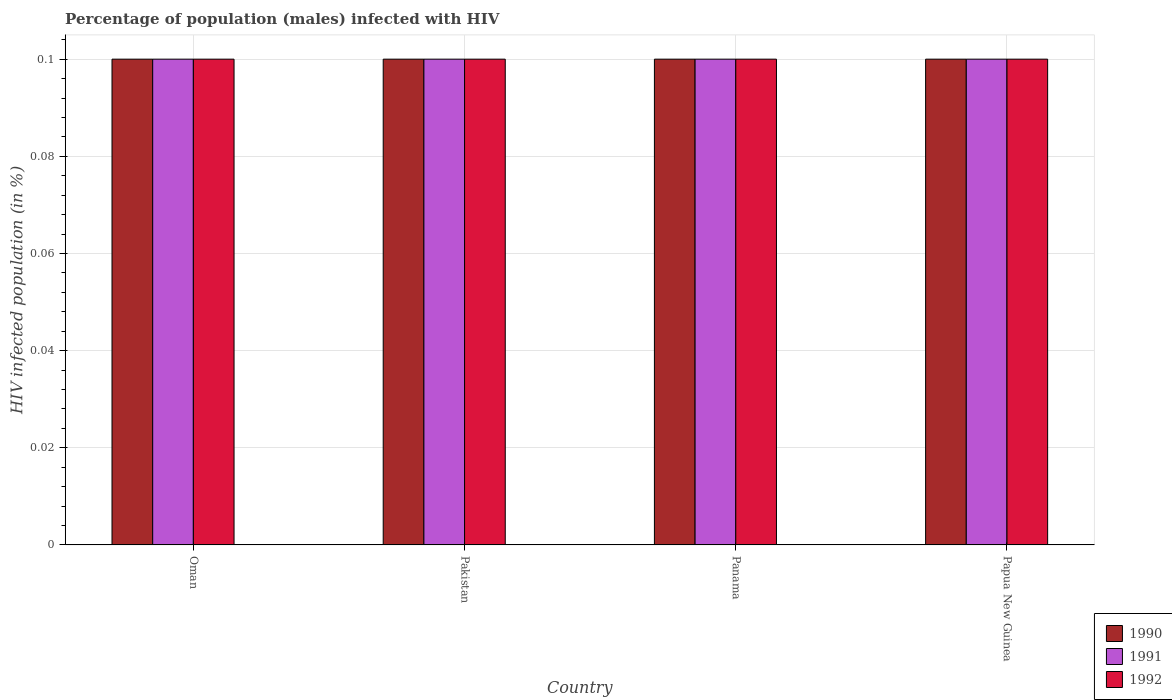How many groups of bars are there?
Give a very brief answer. 4. How many bars are there on the 2nd tick from the right?
Ensure brevity in your answer.  3. In how many cases, is the number of bars for a given country not equal to the number of legend labels?
Make the answer very short. 0. What is the percentage of HIV infected male population in 1992 in Pakistan?
Your response must be concise. 0.1. In which country was the percentage of HIV infected male population in 1992 maximum?
Provide a succinct answer. Oman. In which country was the percentage of HIV infected male population in 1990 minimum?
Ensure brevity in your answer.  Oman. What is the total percentage of HIV infected male population in 1990 in the graph?
Provide a short and direct response. 0.4. What is the difference between the percentage of HIV infected male population in 1992 in Papua New Guinea and the percentage of HIV infected male population in 1990 in Panama?
Give a very brief answer. 0. What is the average percentage of HIV infected male population in 1990 per country?
Provide a succinct answer. 0.1. What is the ratio of the percentage of HIV infected male population in 1990 in Oman to that in Papua New Guinea?
Your answer should be very brief. 1. Is the percentage of HIV infected male population in 1990 in Oman less than that in Pakistan?
Offer a very short reply. No. Is the difference between the percentage of HIV infected male population in 1992 in Oman and Pakistan greater than the difference between the percentage of HIV infected male population in 1991 in Oman and Pakistan?
Your answer should be very brief. No. What is the difference between the highest and the lowest percentage of HIV infected male population in 1991?
Provide a short and direct response. 0. In how many countries, is the percentage of HIV infected male population in 1992 greater than the average percentage of HIV infected male population in 1992 taken over all countries?
Offer a terse response. 0. Is the sum of the percentage of HIV infected male population in 1992 in Pakistan and Papua New Guinea greater than the maximum percentage of HIV infected male population in 1990 across all countries?
Your answer should be very brief. Yes. What does the 2nd bar from the left in Papua New Guinea represents?
Your answer should be compact. 1991. Is it the case that in every country, the sum of the percentage of HIV infected male population in 1990 and percentage of HIV infected male population in 1992 is greater than the percentage of HIV infected male population in 1991?
Your answer should be very brief. Yes. How many bars are there?
Your answer should be very brief. 12. How many countries are there in the graph?
Your answer should be compact. 4. Are the values on the major ticks of Y-axis written in scientific E-notation?
Provide a short and direct response. No. Does the graph contain grids?
Give a very brief answer. Yes. Where does the legend appear in the graph?
Your answer should be very brief. Bottom right. What is the title of the graph?
Make the answer very short. Percentage of population (males) infected with HIV. Does "1965" appear as one of the legend labels in the graph?
Provide a short and direct response. No. What is the label or title of the Y-axis?
Your answer should be very brief. HIV infected population (in %). What is the HIV infected population (in %) in 1992 in Oman?
Your answer should be very brief. 0.1. What is the HIV infected population (in %) in 1990 in Pakistan?
Offer a very short reply. 0.1. What is the HIV infected population (in %) of 1992 in Panama?
Ensure brevity in your answer.  0.1. What is the HIV infected population (in %) in 1990 in Papua New Guinea?
Ensure brevity in your answer.  0.1. What is the HIV infected population (in %) of 1992 in Papua New Guinea?
Make the answer very short. 0.1. Across all countries, what is the maximum HIV infected population (in %) in 1992?
Keep it short and to the point. 0.1. Across all countries, what is the minimum HIV infected population (in %) of 1990?
Provide a succinct answer. 0.1. Across all countries, what is the minimum HIV infected population (in %) in 1992?
Your answer should be very brief. 0.1. What is the total HIV infected population (in %) in 1990 in the graph?
Make the answer very short. 0.4. What is the total HIV infected population (in %) in 1992 in the graph?
Provide a succinct answer. 0.4. What is the difference between the HIV infected population (in %) of 1990 in Oman and that in Pakistan?
Make the answer very short. 0. What is the difference between the HIV infected population (in %) of 1991 in Oman and that in Pakistan?
Your response must be concise. 0. What is the difference between the HIV infected population (in %) of 1990 in Oman and that in Panama?
Give a very brief answer. 0. What is the difference between the HIV infected population (in %) of 1991 in Oman and that in Panama?
Give a very brief answer. 0. What is the difference between the HIV infected population (in %) in 1991 in Oman and that in Papua New Guinea?
Give a very brief answer. 0. What is the difference between the HIV infected population (in %) of 1992 in Oman and that in Papua New Guinea?
Offer a terse response. 0. What is the difference between the HIV infected population (in %) of 1990 in Pakistan and that in Panama?
Give a very brief answer. 0. What is the difference between the HIV infected population (in %) of 1991 in Pakistan and that in Panama?
Ensure brevity in your answer.  0. What is the difference between the HIV infected population (in %) in 1990 in Panama and that in Papua New Guinea?
Your answer should be compact. 0. What is the difference between the HIV infected population (in %) in 1991 in Panama and that in Papua New Guinea?
Your answer should be compact. 0. What is the difference between the HIV infected population (in %) of 1990 in Oman and the HIV infected population (in %) of 1991 in Pakistan?
Provide a short and direct response. 0. What is the difference between the HIV infected population (in %) of 1991 in Oman and the HIV infected population (in %) of 1992 in Pakistan?
Ensure brevity in your answer.  0. What is the difference between the HIV infected population (in %) in 1990 in Oman and the HIV infected population (in %) in 1991 in Panama?
Provide a succinct answer. 0. What is the difference between the HIV infected population (in %) of 1990 in Oman and the HIV infected population (in %) of 1991 in Papua New Guinea?
Offer a terse response. 0. What is the difference between the HIV infected population (in %) in 1991 in Oman and the HIV infected population (in %) in 1992 in Papua New Guinea?
Your response must be concise. 0. What is the difference between the HIV infected population (in %) in 1990 in Pakistan and the HIV infected population (in %) in 1991 in Papua New Guinea?
Offer a terse response. 0. What is the difference between the HIV infected population (in %) of 1991 in Pakistan and the HIV infected population (in %) of 1992 in Papua New Guinea?
Keep it short and to the point. 0. What is the difference between the HIV infected population (in %) of 1990 in Panama and the HIV infected population (in %) of 1991 in Papua New Guinea?
Your answer should be compact. 0. What is the difference between the HIV infected population (in %) of 1991 in Panama and the HIV infected population (in %) of 1992 in Papua New Guinea?
Offer a terse response. 0. What is the average HIV infected population (in %) of 1992 per country?
Provide a short and direct response. 0.1. What is the difference between the HIV infected population (in %) of 1990 and HIV infected population (in %) of 1992 in Oman?
Offer a terse response. 0. What is the difference between the HIV infected population (in %) of 1991 and HIV infected population (in %) of 1992 in Oman?
Give a very brief answer. 0. What is the difference between the HIV infected population (in %) of 1991 and HIV infected population (in %) of 1992 in Pakistan?
Give a very brief answer. 0. What is the difference between the HIV infected population (in %) of 1990 and HIV infected population (in %) of 1991 in Panama?
Your answer should be compact. 0. What is the difference between the HIV infected population (in %) in 1990 and HIV infected population (in %) in 1992 in Panama?
Your answer should be very brief. 0. What is the difference between the HIV infected population (in %) of 1991 and HIV infected population (in %) of 1992 in Panama?
Provide a short and direct response. 0. What is the difference between the HIV infected population (in %) of 1990 and HIV infected population (in %) of 1991 in Papua New Guinea?
Provide a succinct answer. 0. What is the difference between the HIV infected population (in %) of 1991 and HIV infected population (in %) of 1992 in Papua New Guinea?
Give a very brief answer. 0. What is the ratio of the HIV infected population (in %) of 1991 in Oman to that in Papua New Guinea?
Your answer should be compact. 1. What is the ratio of the HIV infected population (in %) of 1991 in Pakistan to that in Panama?
Your answer should be compact. 1. What is the ratio of the HIV infected population (in %) of 1991 in Pakistan to that in Papua New Guinea?
Offer a very short reply. 1. What is the ratio of the HIV infected population (in %) of 1992 in Panama to that in Papua New Guinea?
Give a very brief answer. 1. What is the difference between the highest and the second highest HIV infected population (in %) of 1991?
Make the answer very short. 0. What is the difference between the highest and the second highest HIV infected population (in %) in 1992?
Give a very brief answer. 0. What is the difference between the highest and the lowest HIV infected population (in %) in 1990?
Keep it short and to the point. 0. What is the difference between the highest and the lowest HIV infected population (in %) of 1992?
Make the answer very short. 0. 